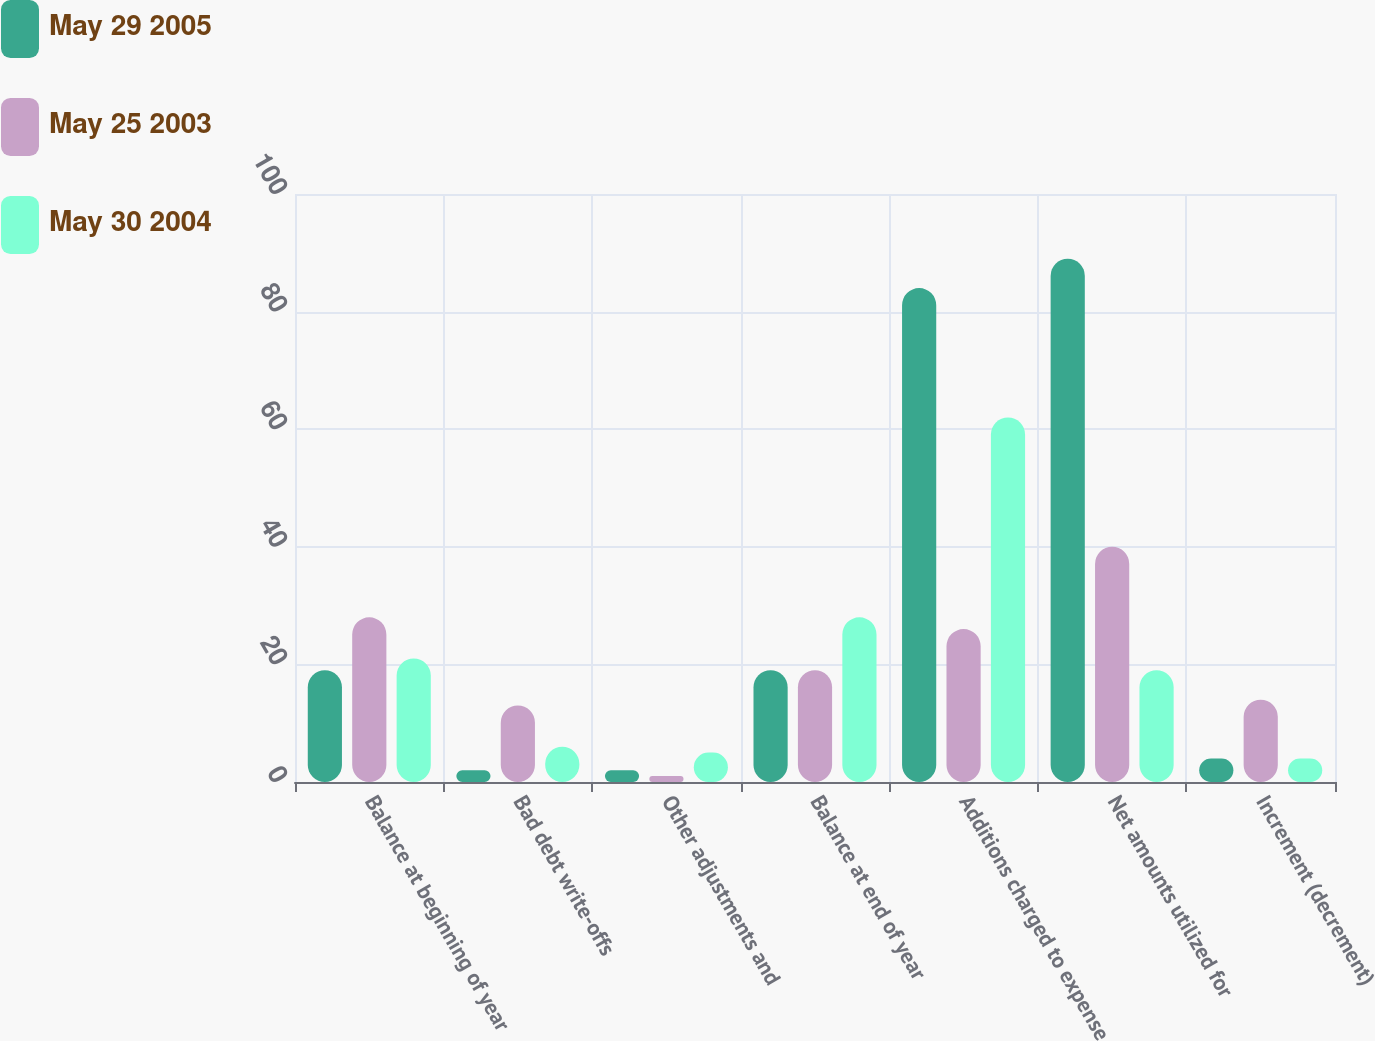<chart> <loc_0><loc_0><loc_500><loc_500><stacked_bar_chart><ecel><fcel>Balance at beginning of year<fcel>Bad debt write-offs<fcel>Other adjustments and<fcel>Balance at end of year<fcel>Additions charged to expense<fcel>Net amounts utilized for<fcel>Increment (decrement)<nl><fcel>May 29 2005<fcel>19<fcel>2<fcel>2<fcel>19<fcel>84<fcel>89<fcel>4<nl><fcel>May 25 2003<fcel>28<fcel>13<fcel>1<fcel>19<fcel>26<fcel>40<fcel>14<nl><fcel>May 30 2004<fcel>21<fcel>6<fcel>5<fcel>28<fcel>62<fcel>19<fcel>4<nl></chart> 